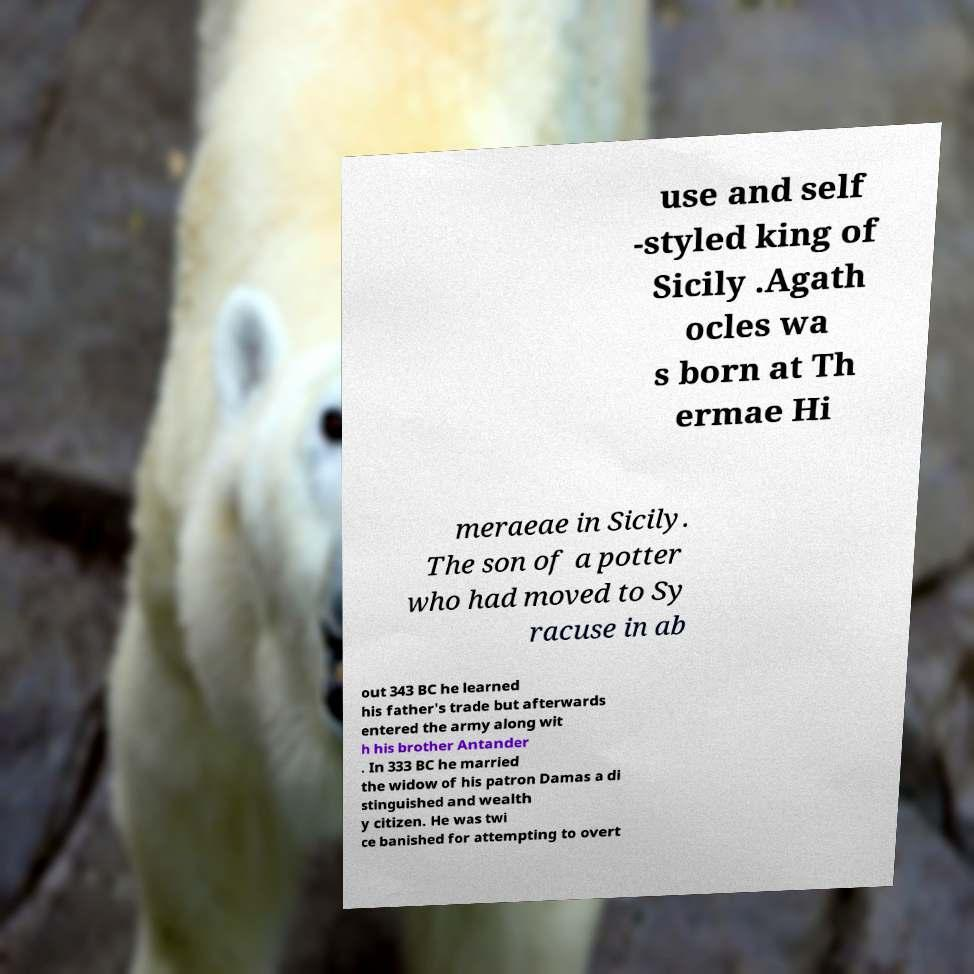Could you assist in decoding the text presented in this image and type it out clearly? use and self -styled king of Sicily .Agath ocles wa s born at Th ermae Hi meraeae in Sicily. The son of a potter who had moved to Sy racuse in ab out 343 BC he learned his father's trade but afterwards entered the army along wit h his brother Antander . In 333 BC he married the widow of his patron Damas a di stinguished and wealth y citizen. He was twi ce banished for attempting to overt 